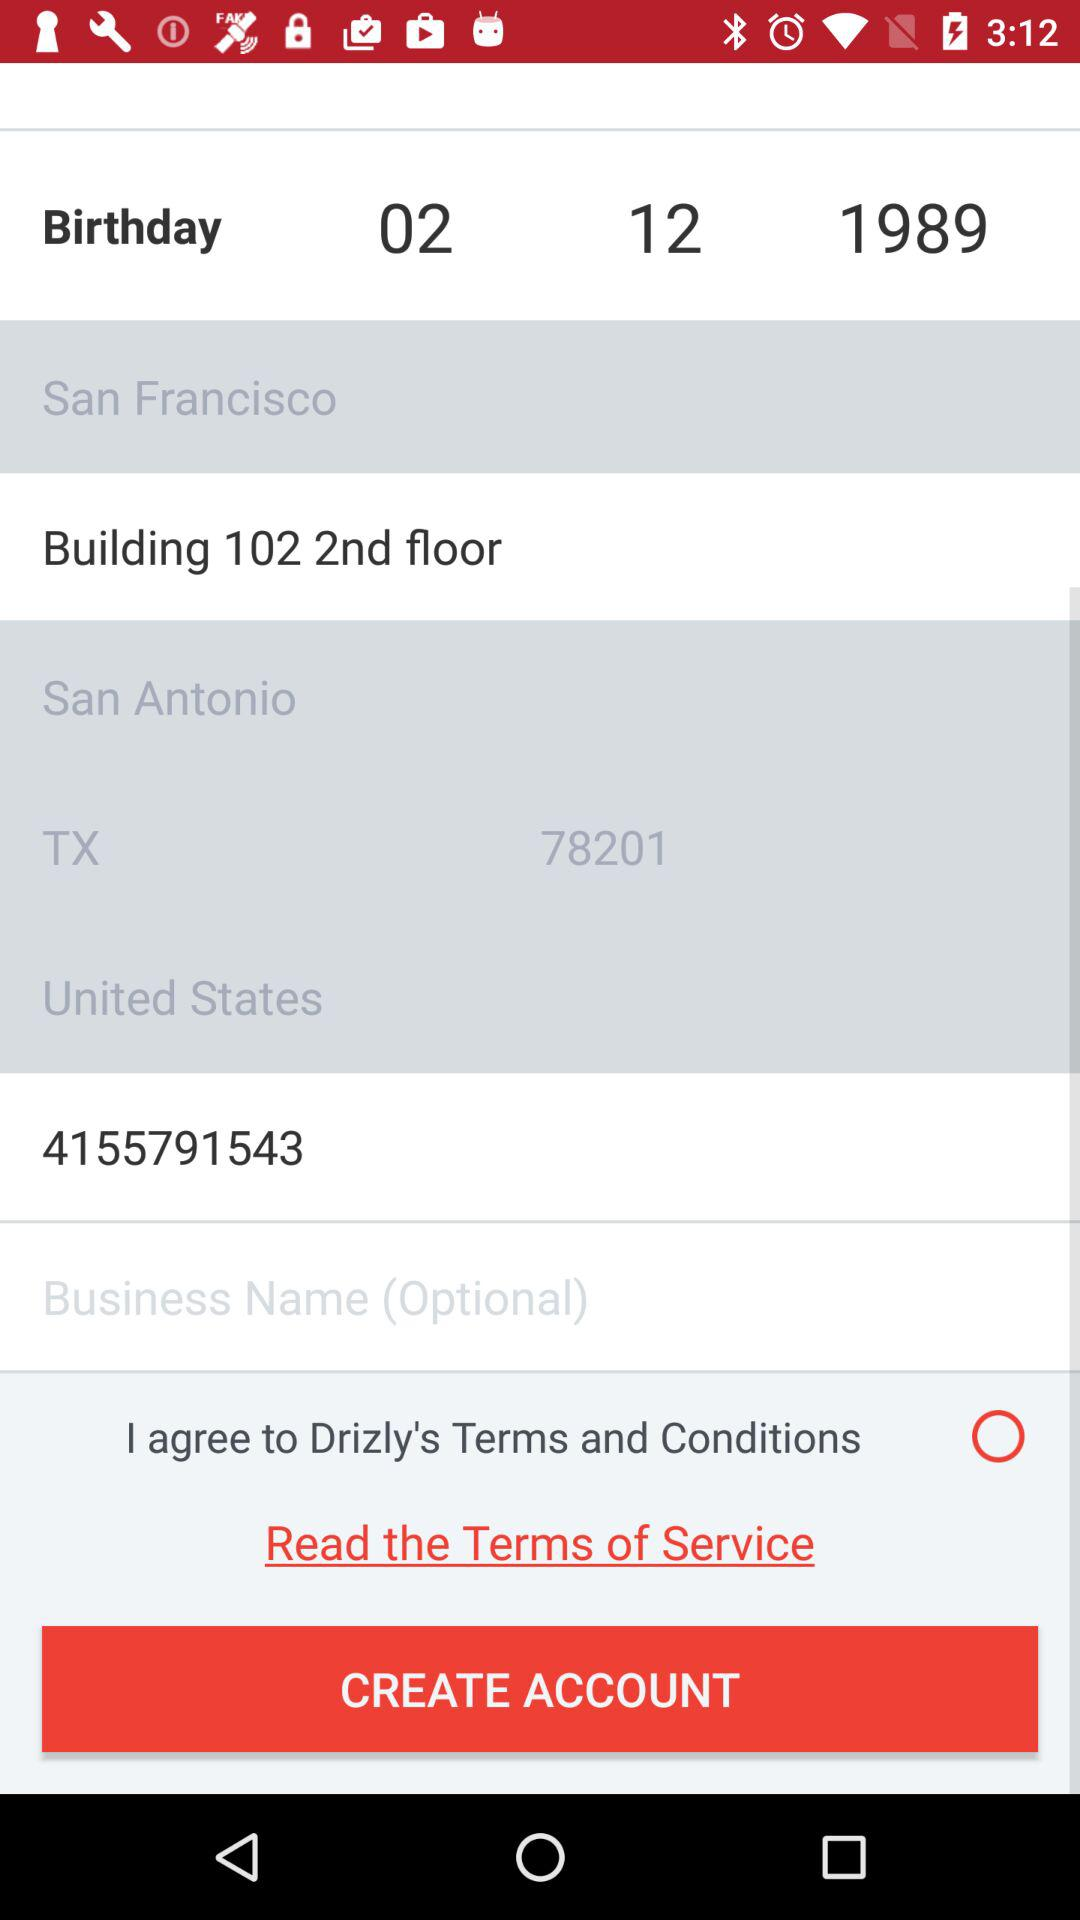What is the postal code? The postal code is 78201. 